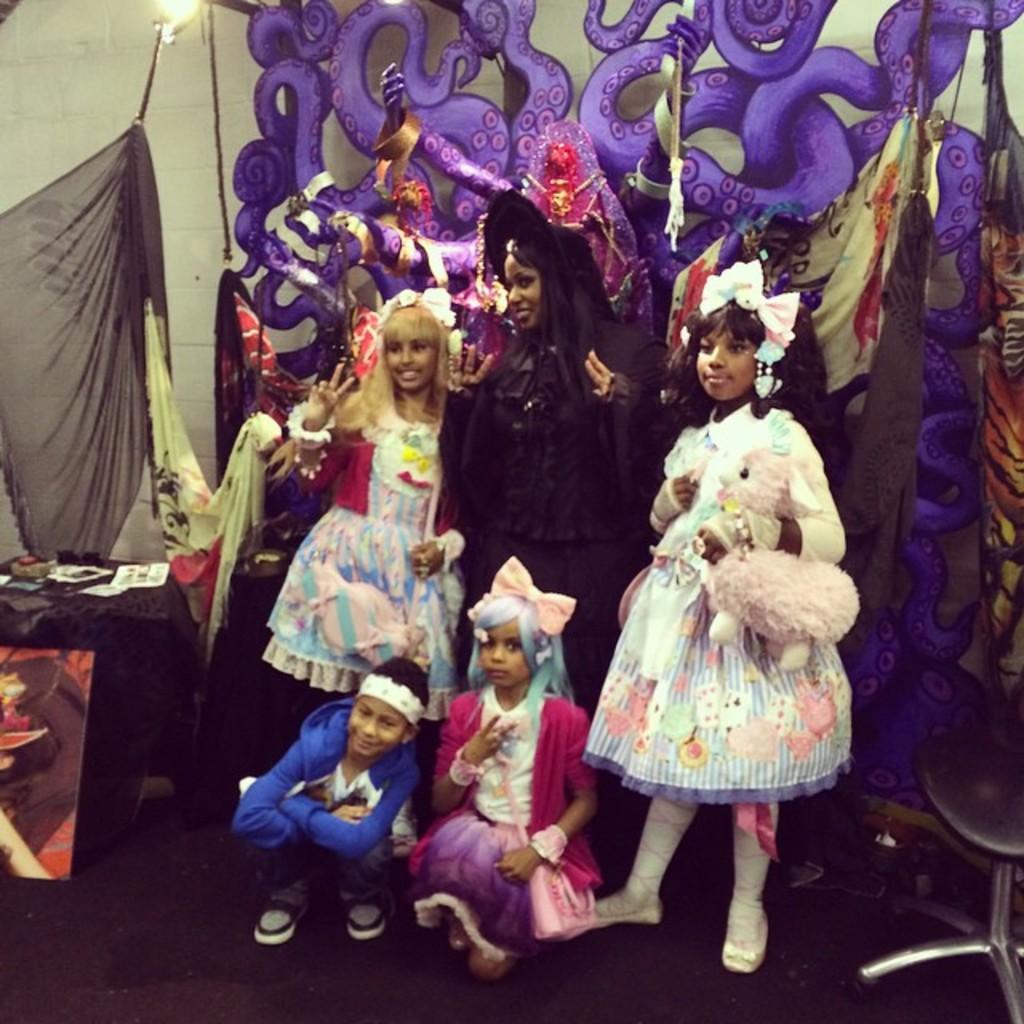Can you describe this image briefly? In this image we can see people standing on the floor and some are sitting on the floor by wearing costumes. In the background we can see a table and decors. 